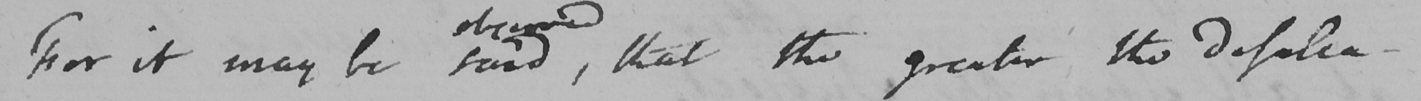What is written in this line of handwriting? For it may be said  , that the greater the defalca- 